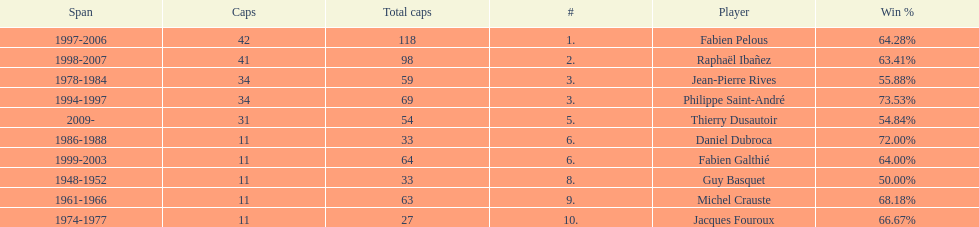How long did michel crauste serve as captain? 1961-1966. 